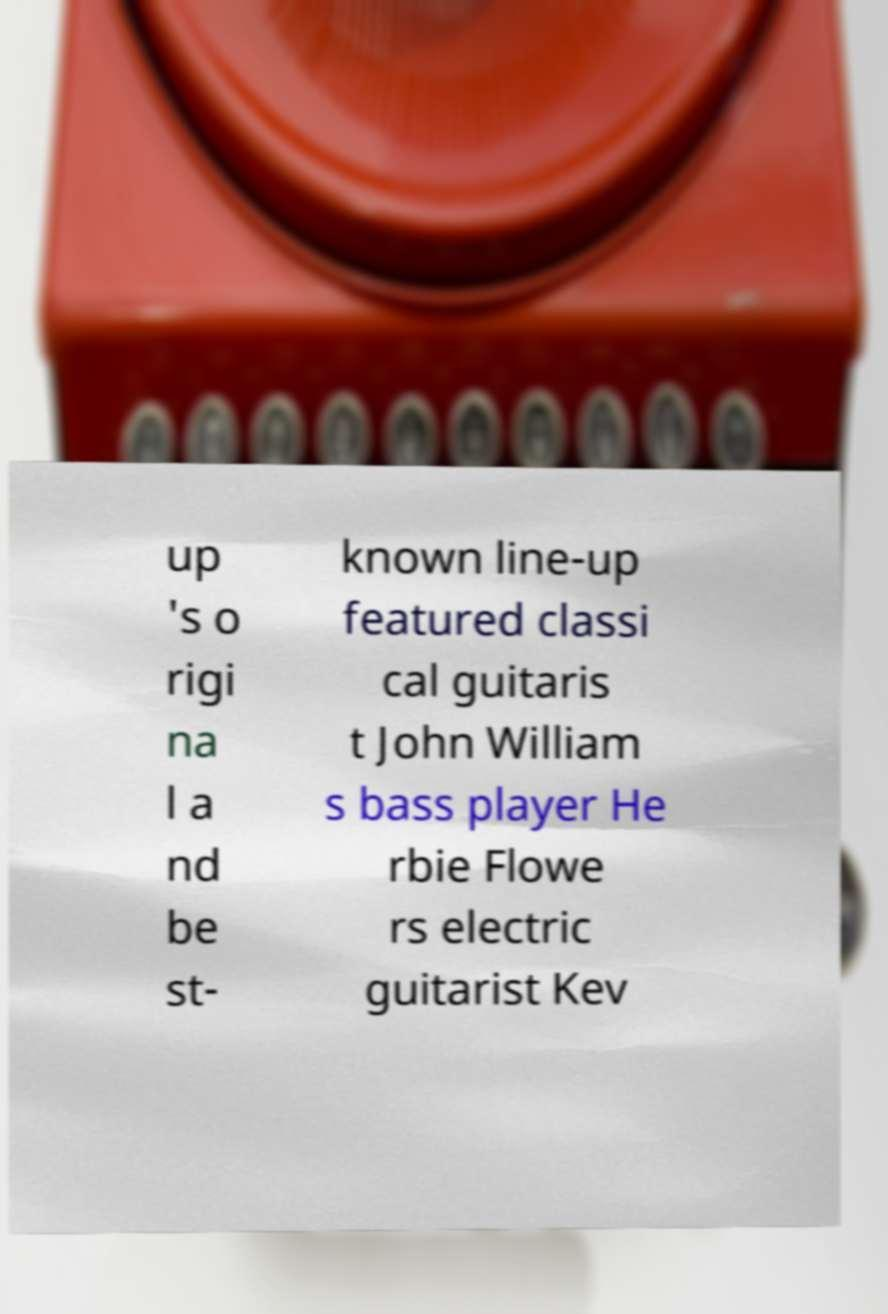What messages or text are displayed in this image? I need them in a readable, typed format. up 's o rigi na l a nd be st- known line-up featured classi cal guitaris t John William s bass player He rbie Flowe rs electric guitarist Kev 